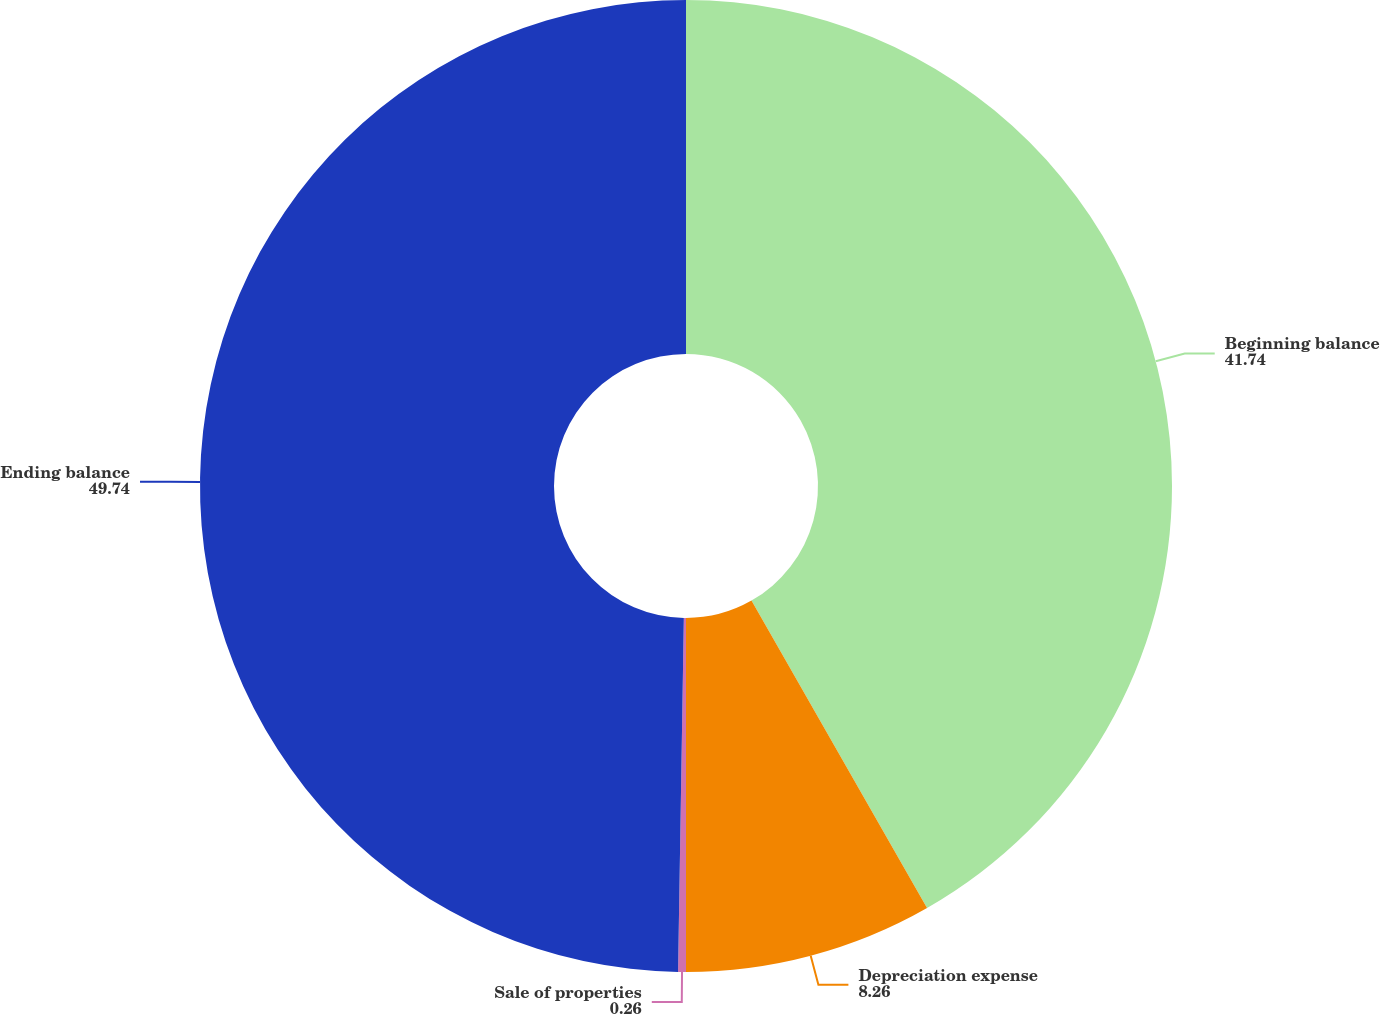Convert chart. <chart><loc_0><loc_0><loc_500><loc_500><pie_chart><fcel>Beginning balance<fcel>Depreciation expense<fcel>Sale of properties<fcel>Ending balance<nl><fcel>41.74%<fcel>8.26%<fcel>0.26%<fcel>49.74%<nl></chart> 